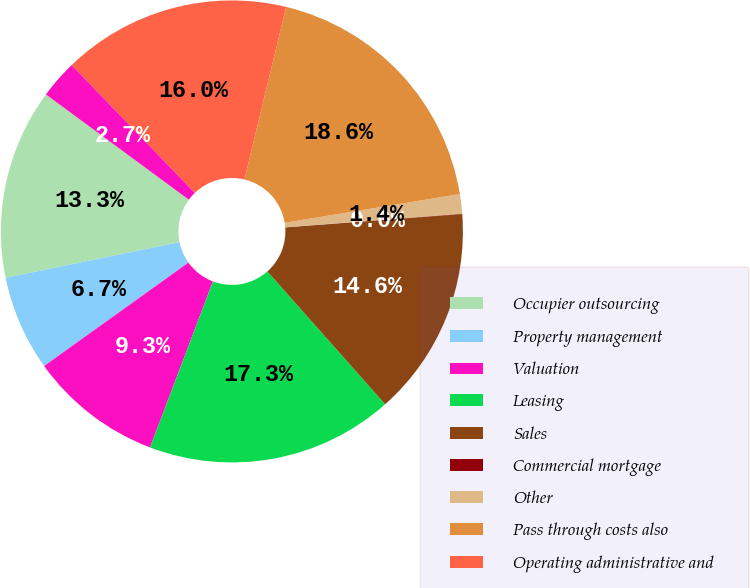Convert chart to OTSL. <chart><loc_0><loc_0><loc_500><loc_500><pie_chart><fcel>Occupier outsourcing<fcel>Property management<fcel>Valuation<fcel>Leasing<fcel>Sales<fcel>Commercial mortgage<fcel>Other<fcel>Pass through costs also<fcel>Operating administrative and<fcel>Depreciation and amortization<nl><fcel>13.32%<fcel>6.68%<fcel>9.34%<fcel>17.31%<fcel>14.65%<fcel>0.03%<fcel>1.36%<fcel>18.64%<fcel>15.98%<fcel>2.69%<nl></chart> 